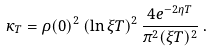<formula> <loc_0><loc_0><loc_500><loc_500>\kappa _ { T } = \rho ( 0 ) ^ { 2 } \left ( \ln \xi T \right ) ^ { 2 } \frac { 4 e ^ { - 2 \eta T } } { \pi ^ { 2 } ( \xi T ) ^ { 2 } } \, .</formula> 